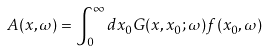Convert formula to latex. <formula><loc_0><loc_0><loc_500><loc_500>A ( x , \omega ) = \int _ { 0 } ^ { \infty } d x _ { 0 } G ( x , x _ { 0 } ; \omega ) f ( x _ { 0 } , \omega )</formula> 